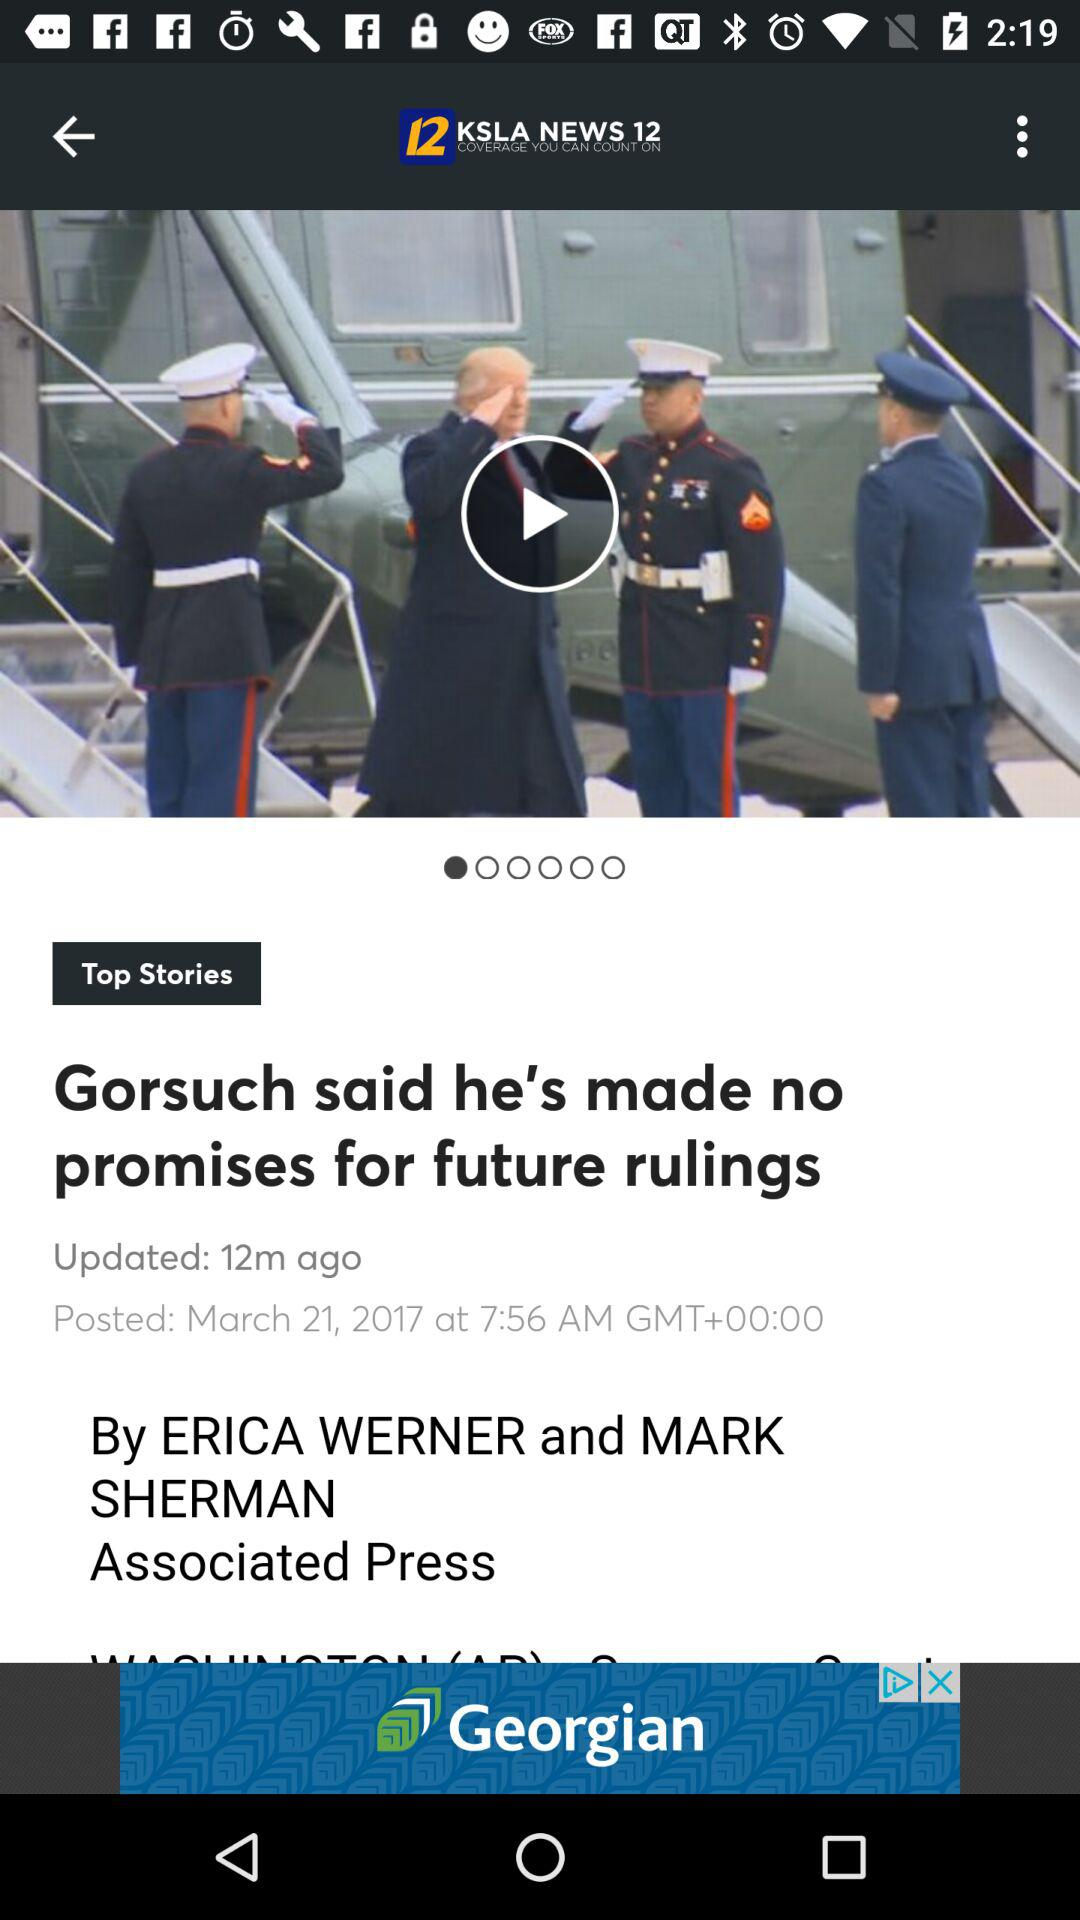What is the given date and time? The given date is March 21, 2017 and the time is 7:56 am. 